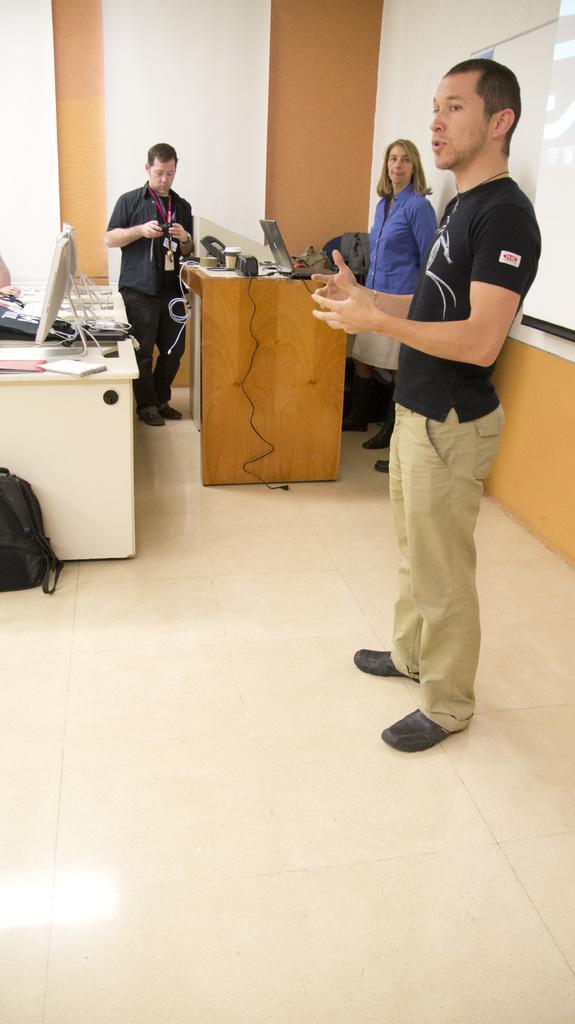How would you summarize this image in a sentence or two? Here in the front vacancy person standing and saying something and beside him we can see a woman standing with a laptop in front of her on the table person in front of her and the other Man Standing and there are tables present and systems present on them and on the left middle we can see a bag present 